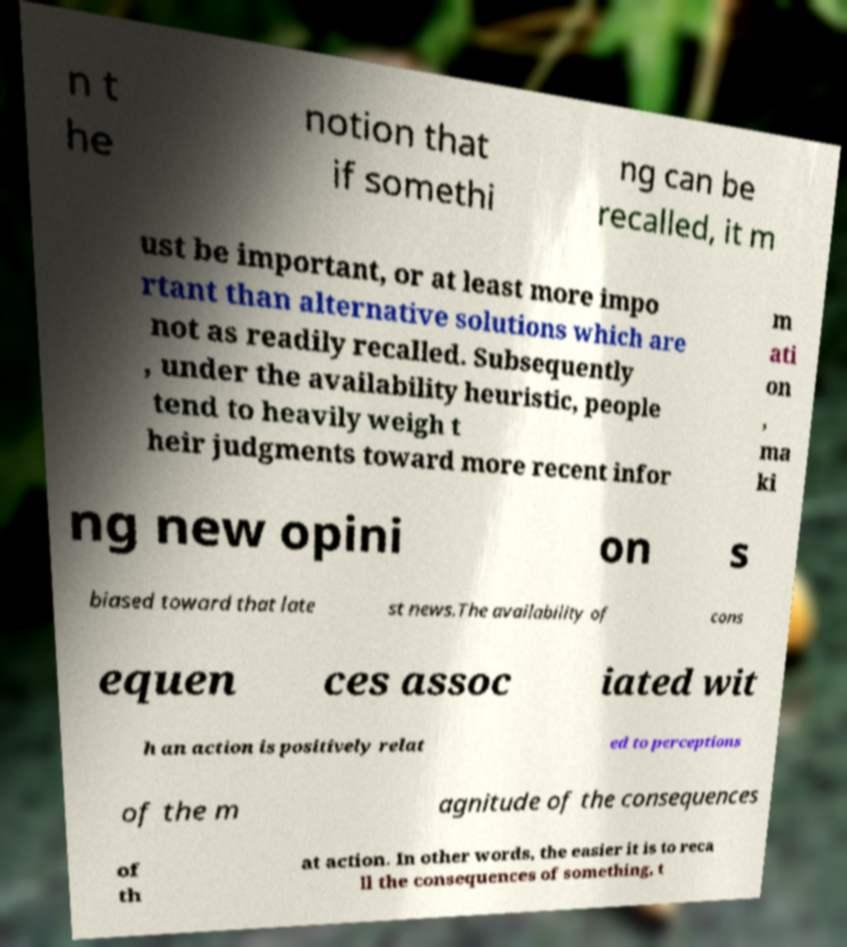Please identify and transcribe the text found in this image. n t he notion that if somethi ng can be recalled, it m ust be important, or at least more impo rtant than alternative solutions which are not as readily recalled. Subsequently , under the availability heuristic, people tend to heavily weigh t heir judgments toward more recent infor m ati on , ma ki ng new opini on s biased toward that late st news.The availability of cons equen ces assoc iated wit h an action is positively relat ed to perceptions of the m agnitude of the consequences of th at action. In other words, the easier it is to reca ll the consequences of something, t 